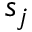<formula> <loc_0><loc_0><loc_500><loc_500>s _ { j }</formula> 